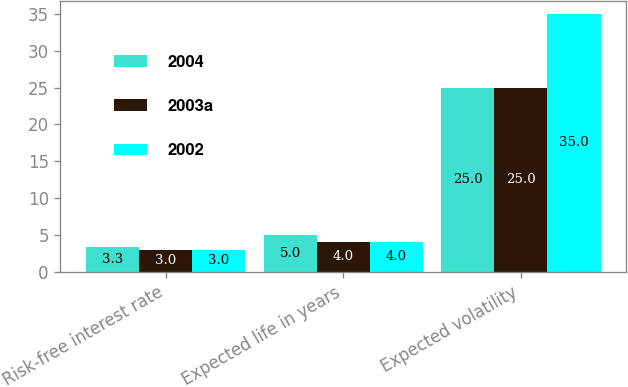Convert chart to OTSL. <chart><loc_0><loc_0><loc_500><loc_500><stacked_bar_chart><ecel><fcel>Risk-free interest rate<fcel>Expected life in years<fcel>Expected volatility<nl><fcel>2004<fcel>3.3<fcel>5<fcel>25<nl><fcel>2003a<fcel>3<fcel>4<fcel>25<nl><fcel>2002<fcel>3<fcel>4<fcel>35<nl></chart> 